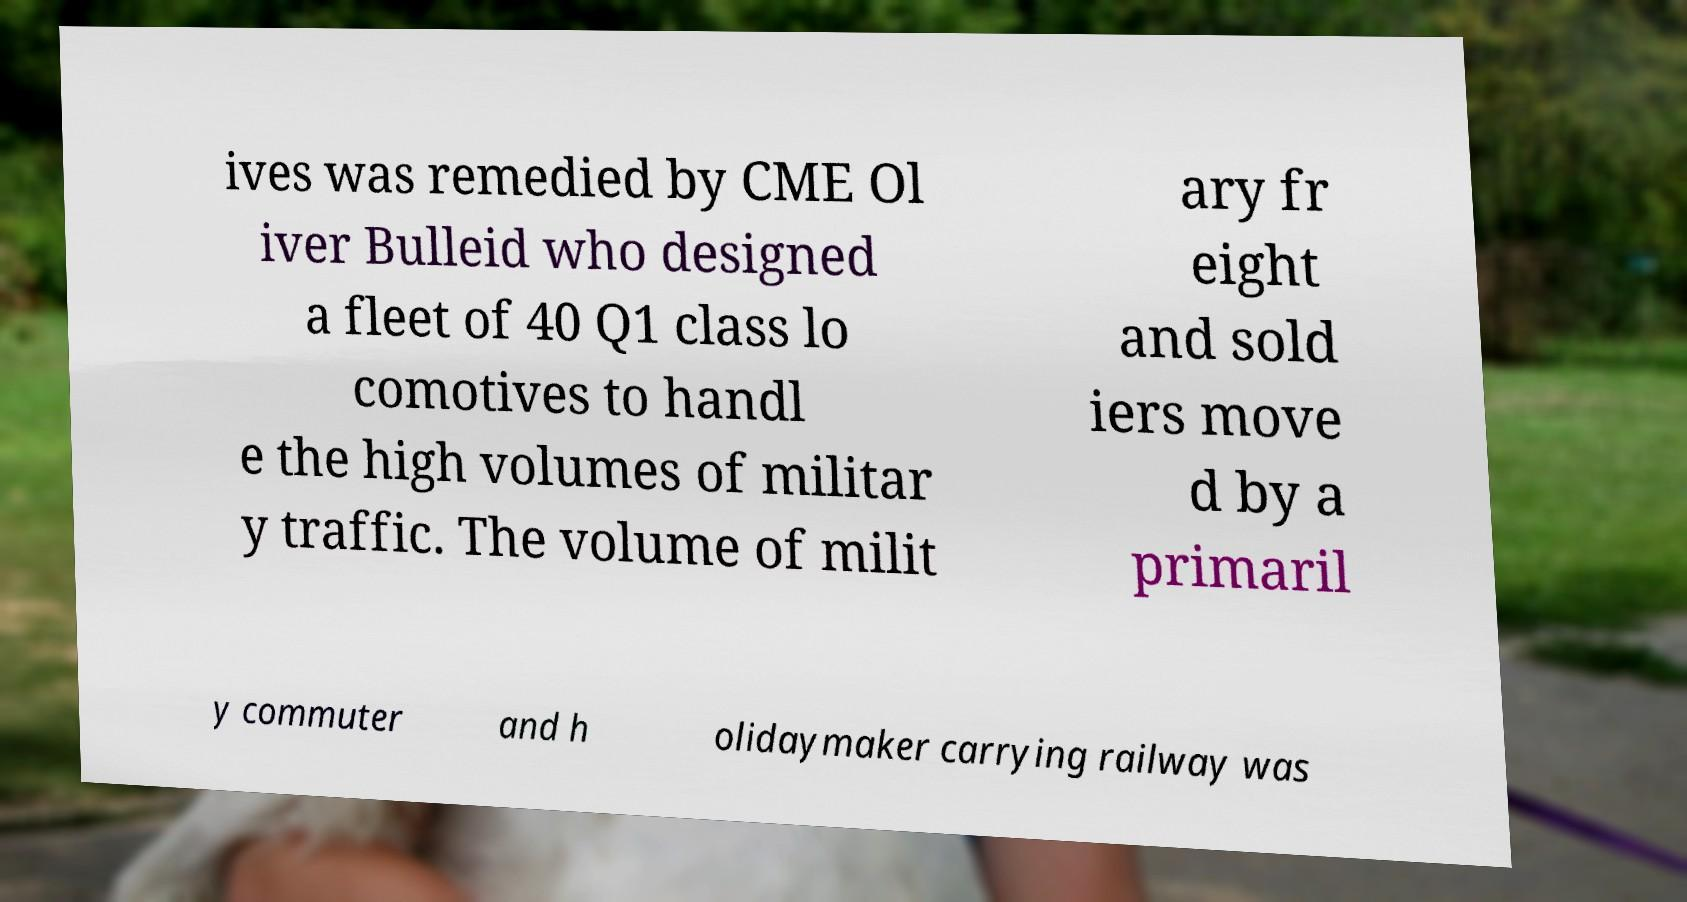I need the written content from this picture converted into text. Can you do that? ives was remedied by CME Ol iver Bulleid who designed a fleet of 40 Q1 class lo comotives to handl e the high volumes of militar y traffic. The volume of milit ary fr eight and sold iers move d by a primaril y commuter and h olidaymaker carrying railway was 